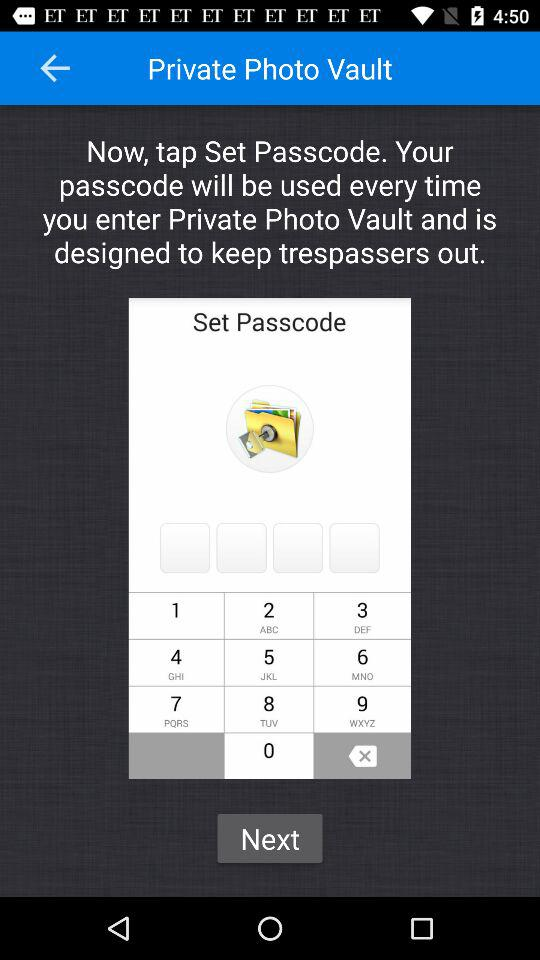What is the entered pass code?
When the provided information is insufficient, respond with <no answer>. <no answer> 